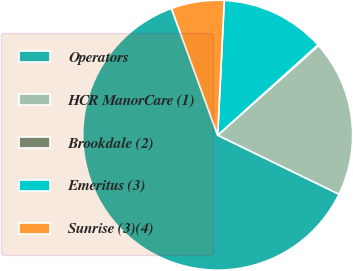Convert chart. <chart><loc_0><loc_0><loc_500><loc_500><pie_chart><fcel>Operators<fcel>HCR ManorCare (1)<fcel>Brookdale (2)<fcel>Emeritus (3)<fcel>Sunrise (3)(4)<nl><fcel>62.24%<fcel>18.76%<fcel>0.12%<fcel>12.55%<fcel>6.34%<nl></chart> 